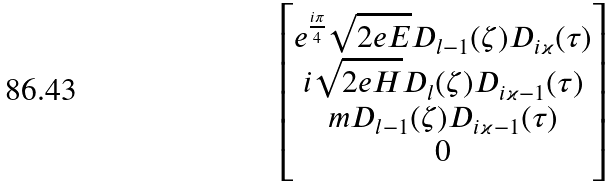Convert formula to latex. <formula><loc_0><loc_0><loc_500><loc_500>\begin{bmatrix} e ^ { \frac { i \pi } 4 } \sqrt { 2 e E } D _ { l - 1 } ( \zeta ) D _ { i \varkappa } ( \tau ) \\ i \sqrt { 2 e H } D _ { l } ( \zeta ) D _ { i \varkappa - 1 } ( \tau ) \\ m D _ { l - 1 } ( \zeta ) D _ { i \varkappa - 1 } ( \tau ) \\ 0 \end{bmatrix}</formula> 